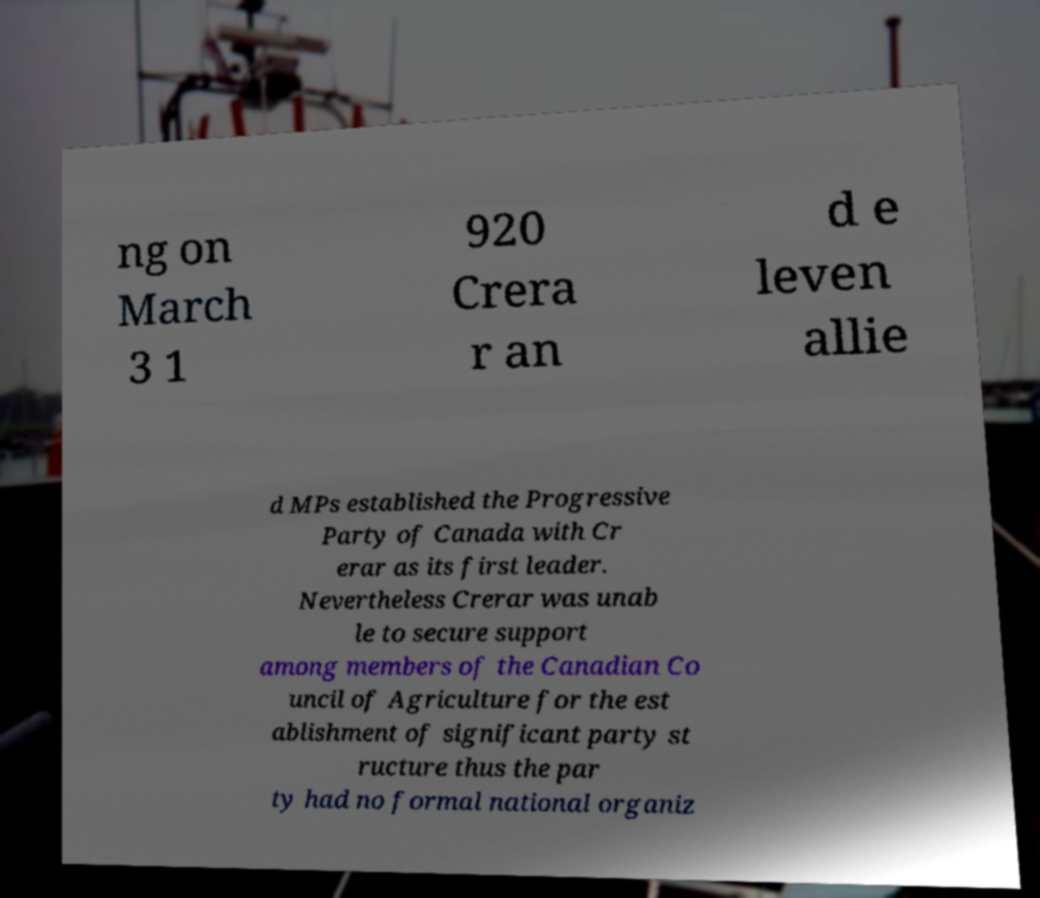I need the written content from this picture converted into text. Can you do that? ng on March 3 1 920 Crera r an d e leven allie d MPs established the Progressive Party of Canada with Cr erar as its first leader. Nevertheless Crerar was unab le to secure support among members of the Canadian Co uncil of Agriculture for the est ablishment of significant party st ructure thus the par ty had no formal national organiz 